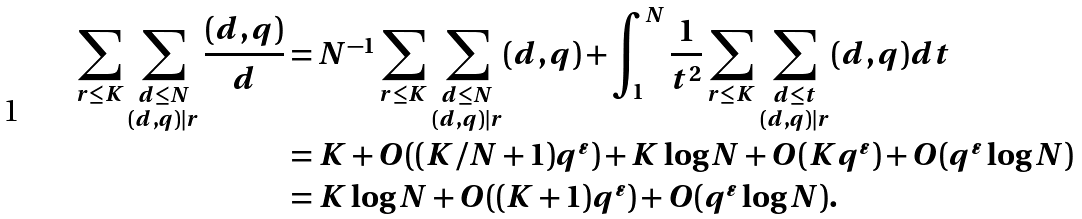<formula> <loc_0><loc_0><loc_500><loc_500>\sum _ { r \leq K } \sum _ { \substack { d \leq N \\ ( d , q ) | r } } \frac { ( d , q ) } { d } & = N ^ { - 1 } \sum _ { r \leq K } \sum _ { \substack { d \leq N \\ ( d , q ) | r } } ( d , q ) + \int _ { 1 } ^ { N } \frac { 1 } { t ^ { 2 } } \sum _ { r \leq K } \sum _ { \substack { d \leq t \\ ( d , q ) | r } } ( d , q ) d t \\ & = K + O ( ( K / N + 1 ) q ^ { \varepsilon } ) + K \log N + O ( K q ^ { \varepsilon } ) + O ( q ^ { \varepsilon } \log N ) \\ & = K \log N + O ( ( K + 1 ) q ^ { \varepsilon } ) + O ( q ^ { \varepsilon } \log N ) .</formula> 